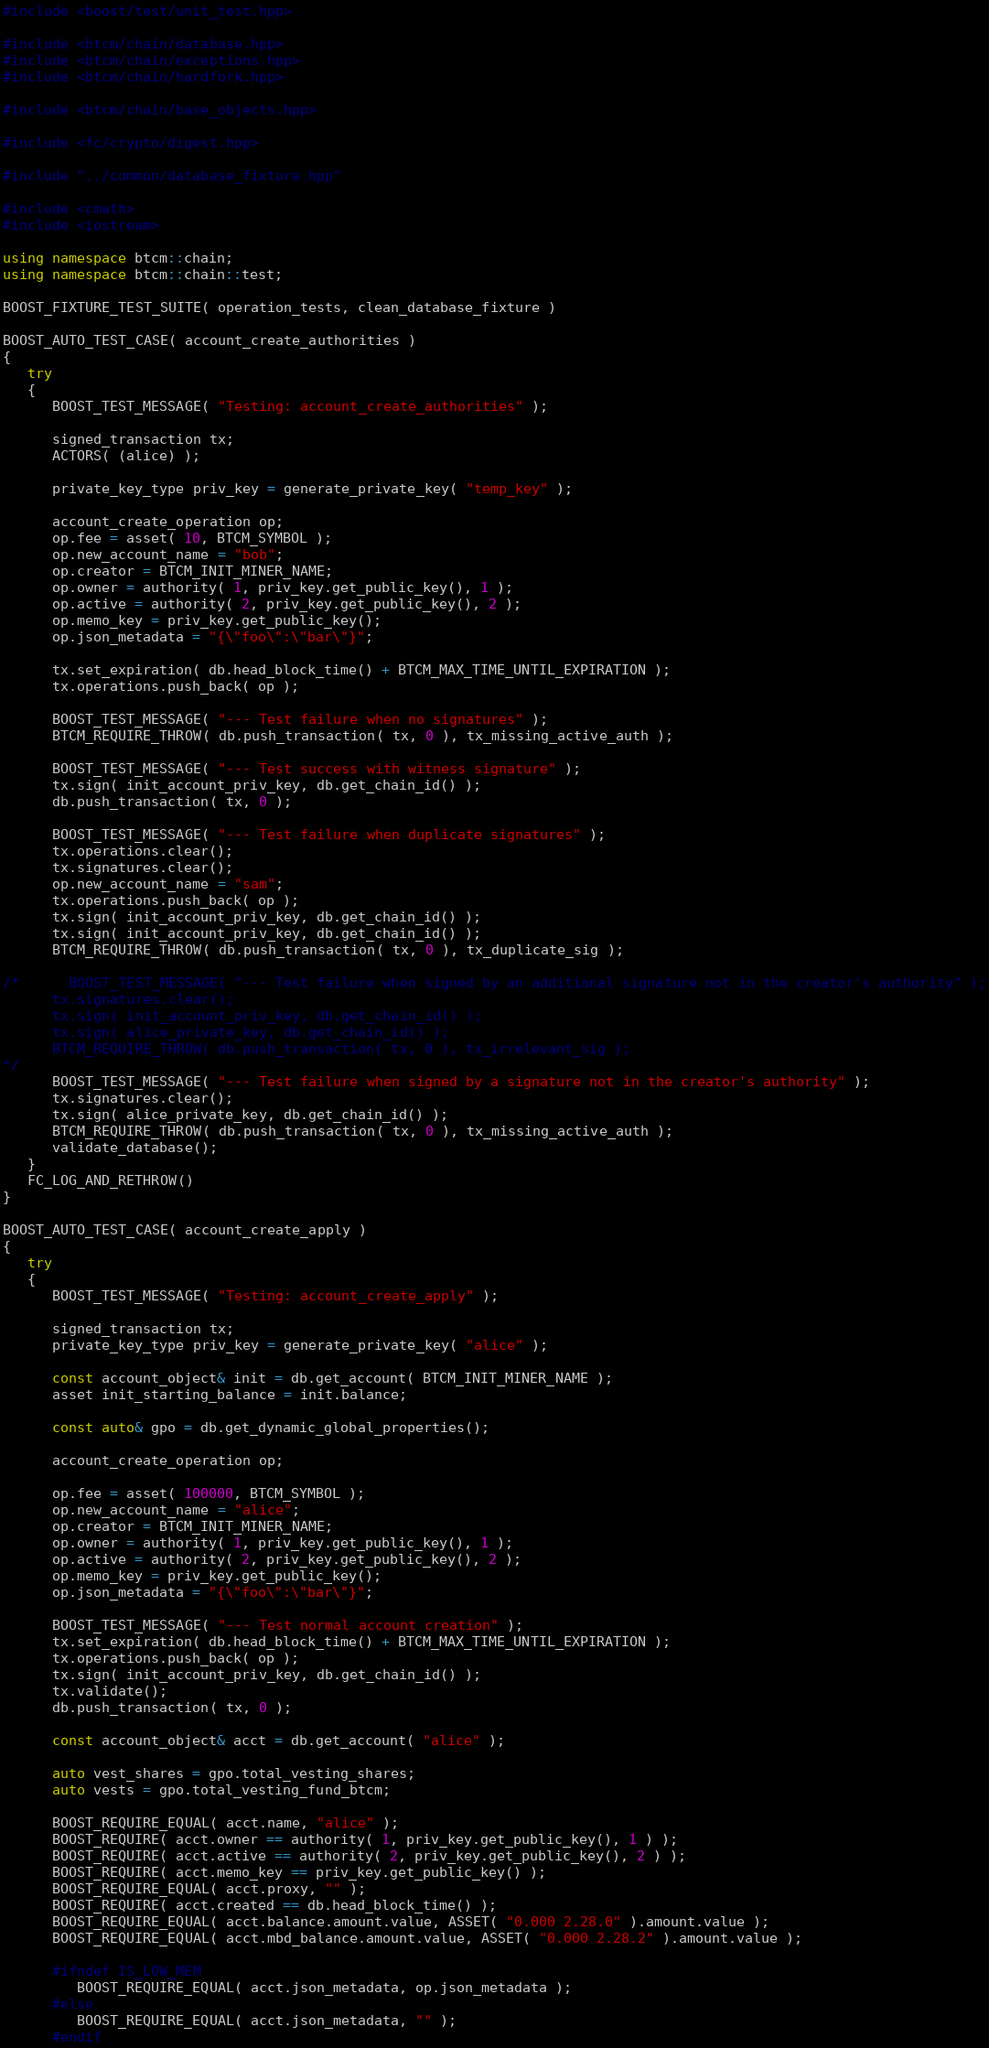Convert code to text. <code><loc_0><loc_0><loc_500><loc_500><_C++_>#include <boost/test/unit_test.hpp>

#include <btcm/chain/database.hpp>
#include <btcm/chain/exceptions.hpp>
#include <btcm/chain/hardfork.hpp>

#include <btcm/chain/base_objects.hpp>

#include <fc/crypto/digest.hpp>

#include "../common/database_fixture.hpp"

#include <cmath>
#include <iostream>

using namespace btcm::chain;
using namespace btcm::chain::test;

BOOST_FIXTURE_TEST_SUITE( operation_tests, clean_database_fixture )

BOOST_AUTO_TEST_CASE( account_create_authorities )
{
   try
   {
      BOOST_TEST_MESSAGE( "Testing: account_create_authorities" );

      signed_transaction tx;
      ACTORS( (alice) );

      private_key_type priv_key = generate_private_key( "temp_key" );

      account_create_operation op;
      op.fee = asset( 10, BTCM_SYMBOL );
      op.new_account_name = "bob";
      op.creator = BTCM_INIT_MINER_NAME;
      op.owner = authority( 1, priv_key.get_public_key(), 1 );
      op.active = authority( 2, priv_key.get_public_key(), 2 );
      op.memo_key = priv_key.get_public_key();
      op.json_metadata = "{\"foo\":\"bar\"}";

      tx.set_expiration( db.head_block_time() + BTCM_MAX_TIME_UNTIL_EXPIRATION );
      tx.operations.push_back( op );

      BOOST_TEST_MESSAGE( "--- Test failure when no signatures" );
      BTCM_REQUIRE_THROW( db.push_transaction( tx, 0 ), tx_missing_active_auth );

      BOOST_TEST_MESSAGE( "--- Test success with witness signature" );
      tx.sign( init_account_priv_key, db.get_chain_id() );
      db.push_transaction( tx, 0 );

      BOOST_TEST_MESSAGE( "--- Test failure when duplicate signatures" );
      tx.operations.clear();
      tx.signatures.clear();
      op.new_account_name = "sam";
      tx.operations.push_back( op );
      tx.sign( init_account_priv_key, db.get_chain_id() );
      tx.sign( init_account_priv_key, db.get_chain_id() );
      BTCM_REQUIRE_THROW( db.push_transaction( tx, 0 ), tx_duplicate_sig );

/*      BOOST_TEST_MESSAGE( "--- Test failure when signed by an additional signature not in the creator's authority" );
      tx.signatures.clear();
      tx.sign( init_account_priv_key, db.get_chain_id() );
      tx.sign( alice_private_key, db.get_chain_id() );
      BTCM_REQUIRE_THROW( db.push_transaction( tx, 0 ), tx_irrelevant_sig );
*/
      BOOST_TEST_MESSAGE( "--- Test failure when signed by a signature not in the creator's authority" );
      tx.signatures.clear();
      tx.sign( alice_private_key, db.get_chain_id() );
      BTCM_REQUIRE_THROW( db.push_transaction( tx, 0 ), tx_missing_active_auth );
      validate_database();
   }
   FC_LOG_AND_RETHROW()
}

BOOST_AUTO_TEST_CASE( account_create_apply )
{
   try
   {
      BOOST_TEST_MESSAGE( "Testing: account_create_apply" );

      signed_transaction tx;
      private_key_type priv_key = generate_private_key( "alice" );

      const account_object& init = db.get_account( BTCM_INIT_MINER_NAME );
      asset init_starting_balance = init.balance;

      const auto& gpo = db.get_dynamic_global_properties();

      account_create_operation op;

      op.fee = asset( 100000, BTCM_SYMBOL );
      op.new_account_name = "alice";
      op.creator = BTCM_INIT_MINER_NAME;
      op.owner = authority( 1, priv_key.get_public_key(), 1 );
      op.active = authority( 2, priv_key.get_public_key(), 2 );
      op.memo_key = priv_key.get_public_key();
      op.json_metadata = "{\"foo\":\"bar\"}";

      BOOST_TEST_MESSAGE( "--- Test normal account creation" );
      tx.set_expiration( db.head_block_time() + BTCM_MAX_TIME_UNTIL_EXPIRATION );
      tx.operations.push_back( op );
      tx.sign( init_account_priv_key, db.get_chain_id() );
      tx.validate();
      db.push_transaction( tx, 0 );

      const account_object& acct = db.get_account( "alice" );

      auto vest_shares = gpo.total_vesting_shares;
      auto vests = gpo.total_vesting_fund_btcm;

      BOOST_REQUIRE_EQUAL( acct.name, "alice" );
      BOOST_REQUIRE( acct.owner == authority( 1, priv_key.get_public_key(), 1 ) );
      BOOST_REQUIRE( acct.active == authority( 2, priv_key.get_public_key(), 2 ) );
      BOOST_REQUIRE( acct.memo_key == priv_key.get_public_key() );
      BOOST_REQUIRE_EQUAL( acct.proxy, "" );
      BOOST_REQUIRE( acct.created == db.head_block_time() );
      BOOST_REQUIRE_EQUAL( acct.balance.amount.value, ASSET( "0.000 2.28.0" ).amount.value );
      BOOST_REQUIRE_EQUAL( acct.mbd_balance.amount.value, ASSET( "0.000 2.28.2" ).amount.value );

      #ifndef IS_LOW_MEM
         BOOST_REQUIRE_EQUAL( acct.json_metadata, op.json_metadata );
      #else
         BOOST_REQUIRE_EQUAL( acct.json_metadata, "" );
      #endif
</code> 